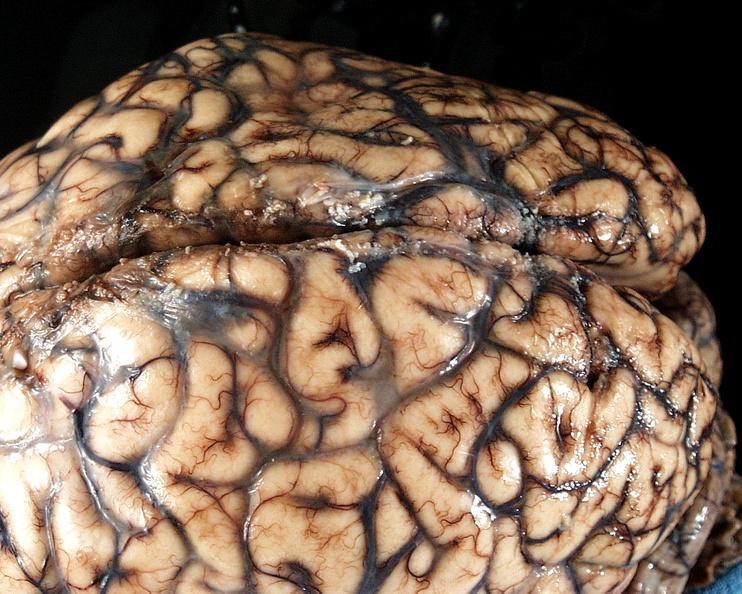what is present?
Answer the question using a single word or phrase. Nervous 